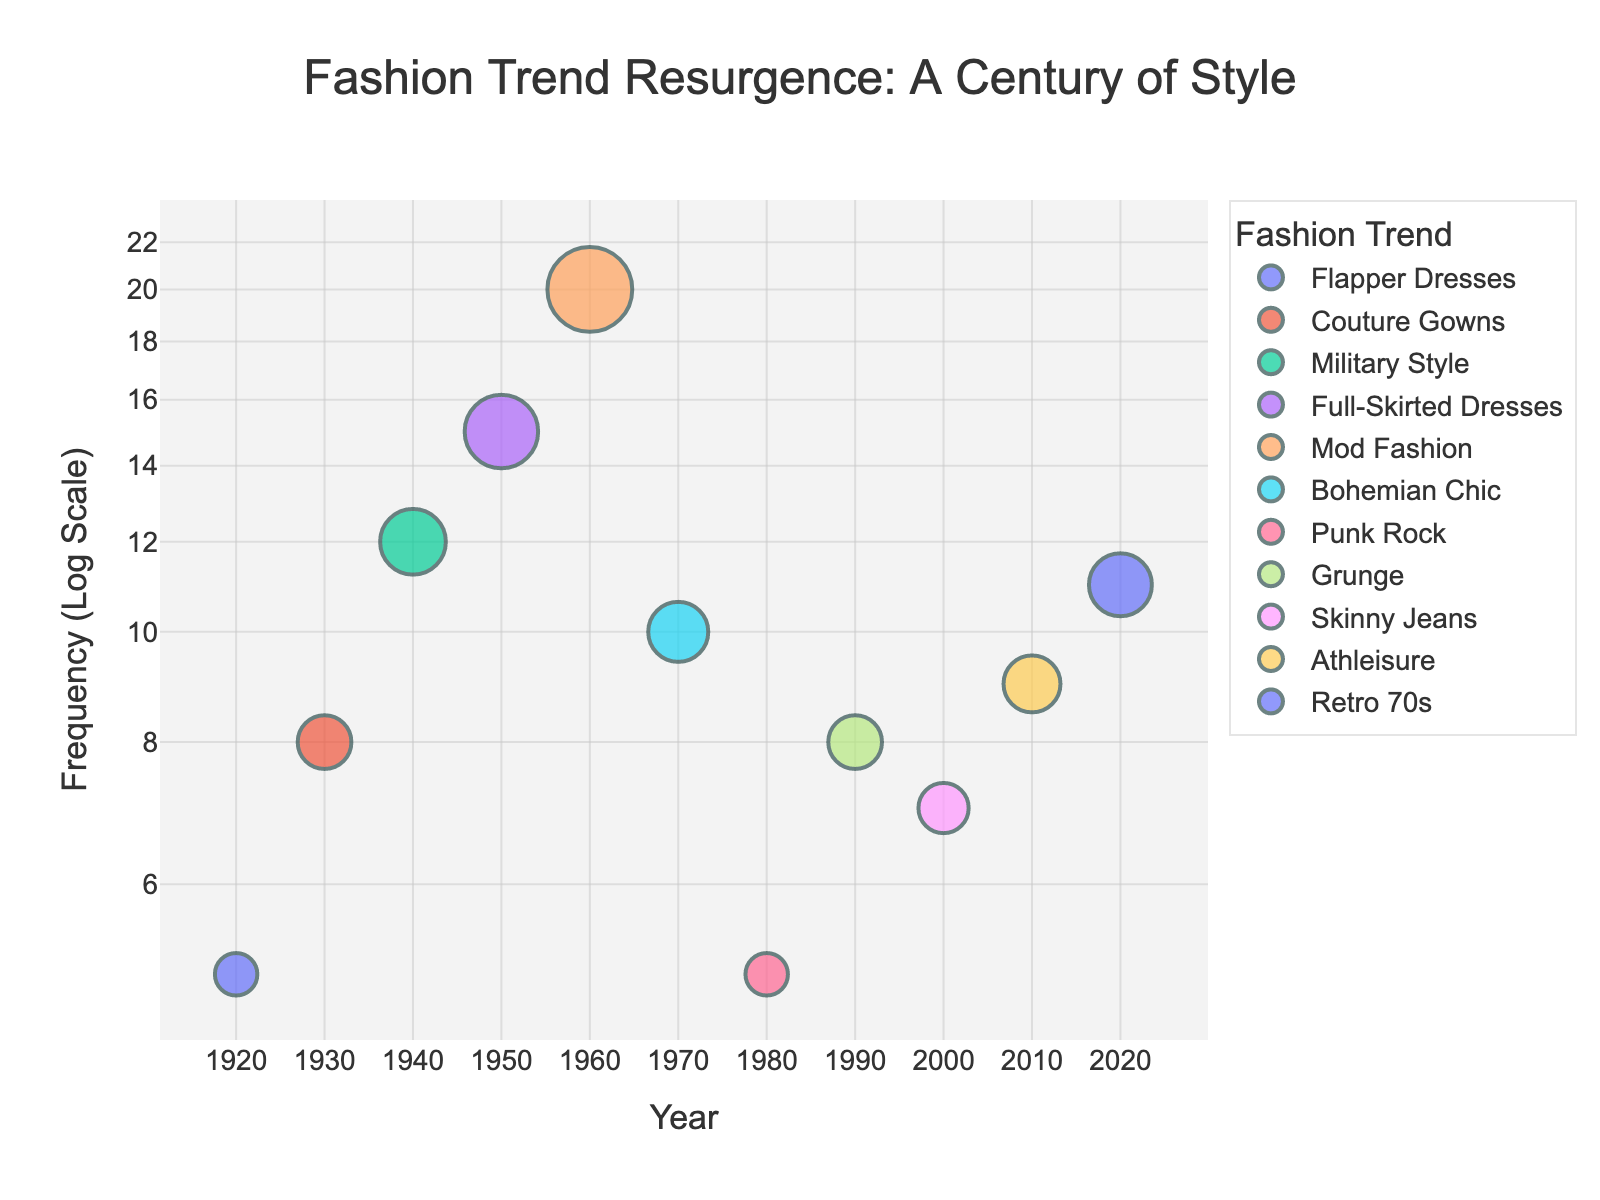What is the title of the figure? The title is usually a text element at the top of the figure, and it is explicitly mentioned in the customization code.
Answer: Fashion Trend Resurgence: A Century of Style What is the frequency of the 'Punk Rock' trend? Locate the data point for the 'Punk Rock' trend and observe its 'Frequency' value on the y-axis. 'Punk Rock' corresponds to the year 1980 with a frequency of 5.
Answer: 5 Which trend has the highest frequency? Identify the data point with the highest position on the y-axis, which represents the maximum frequency. 'Mod Fashion' in 1960 has the highest frequency value of 20.
Answer: Mod Fashion How many trends are there between 1960 and 2020? Count the data points (trends) that fall between the years 1960 and 2020 on the x-axis.
Answer: 6 What is the median frequency value of the trends? Organize the frequency values in ascending order and determine the middle value. Frequencies: 5, 5, 7, 8, 8, 9, 10, 11, 12, 15, 20. The median is the 8th value in this ordered list, which is 9.
Answer: 9 Which trends appear in the 1920s and 2020s? Identify the data points corresponding to the years 1920 and 2020 and note their trend names. In 1920, the trend is 'Flapper Dresses' and in 2020, it is 'Retro 70s'.
Answer: Flapper Dresses, Retro 70s Which trend has the smallest frequency and in what year? Look for the data point with the lowest position on the y-axis. 'Punk Rock' in 1980 has the smallest frequency value of 5.
Answer: Punk Rock in 1980 Compare the frequency of 'Bohemian Chic' in 1970 and 'Athleisure' in 2010. Which is higher? Locate the data points for 'Bohemian Chic' in 1970 and 'Athleisure' in 2010 and compare their y-axis positions. 'Athleisure' in 2010 has a frequency of 9, which is higher than 'Bohemian Chic' in 1970 with a frequency of 10.
Answer: Athleisure in 2010 What is the difference in frequency between 'Grunge' and 'Skinny Jeans'? Find the frequency values of 'Grunge' (8) and 'Skinny Jeans' (7) and calculate their difference: 8 - 7 = 1.
Answer: 1 Which decade has the most diverse fashion trends with distinct names according to the figure? Count the number of unique trends in each decade. The 1960s to 2020 each have one trend, but the specific decade with most diversity needs reviewing the highest number of distinct trend names.
Answer: Multiple Decades, requires closer inspection 